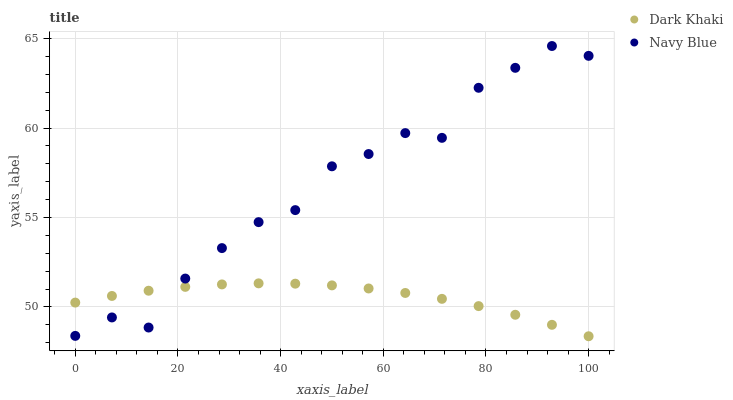Does Dark Khaki have the minimum area under the curve?
Answer yes or no. Yes. Does Navy Blue have the maximum area under the curve?
Answer yes or no. Yes. Does Navy Blue have the minimum area under the curve?
Answer yes or no. No. Is Dark Khaki the smoothest?
Answer yes or no. Yes. Is Navy Blue the roughest?
Answer yes or no. Yes. Is Navy Blue the smoothest?
Answer yes or no. No. Does Dark Khaki have the lowest value?
Answer yes or no. Yes. Does Navy Blue have the lowest value?
Answer yes or no. No. Does Navy Blue have the highest value?
Answer yes or no. Yes. Does Navy Blue intersect Dark Khaki?
Answer yes or no. Yes. Is Navy Blue less than Dark Khaki?
Answer yes or no. No. Is Navy Blue greater than Dark Khaki?
Answer yes or no. No. 